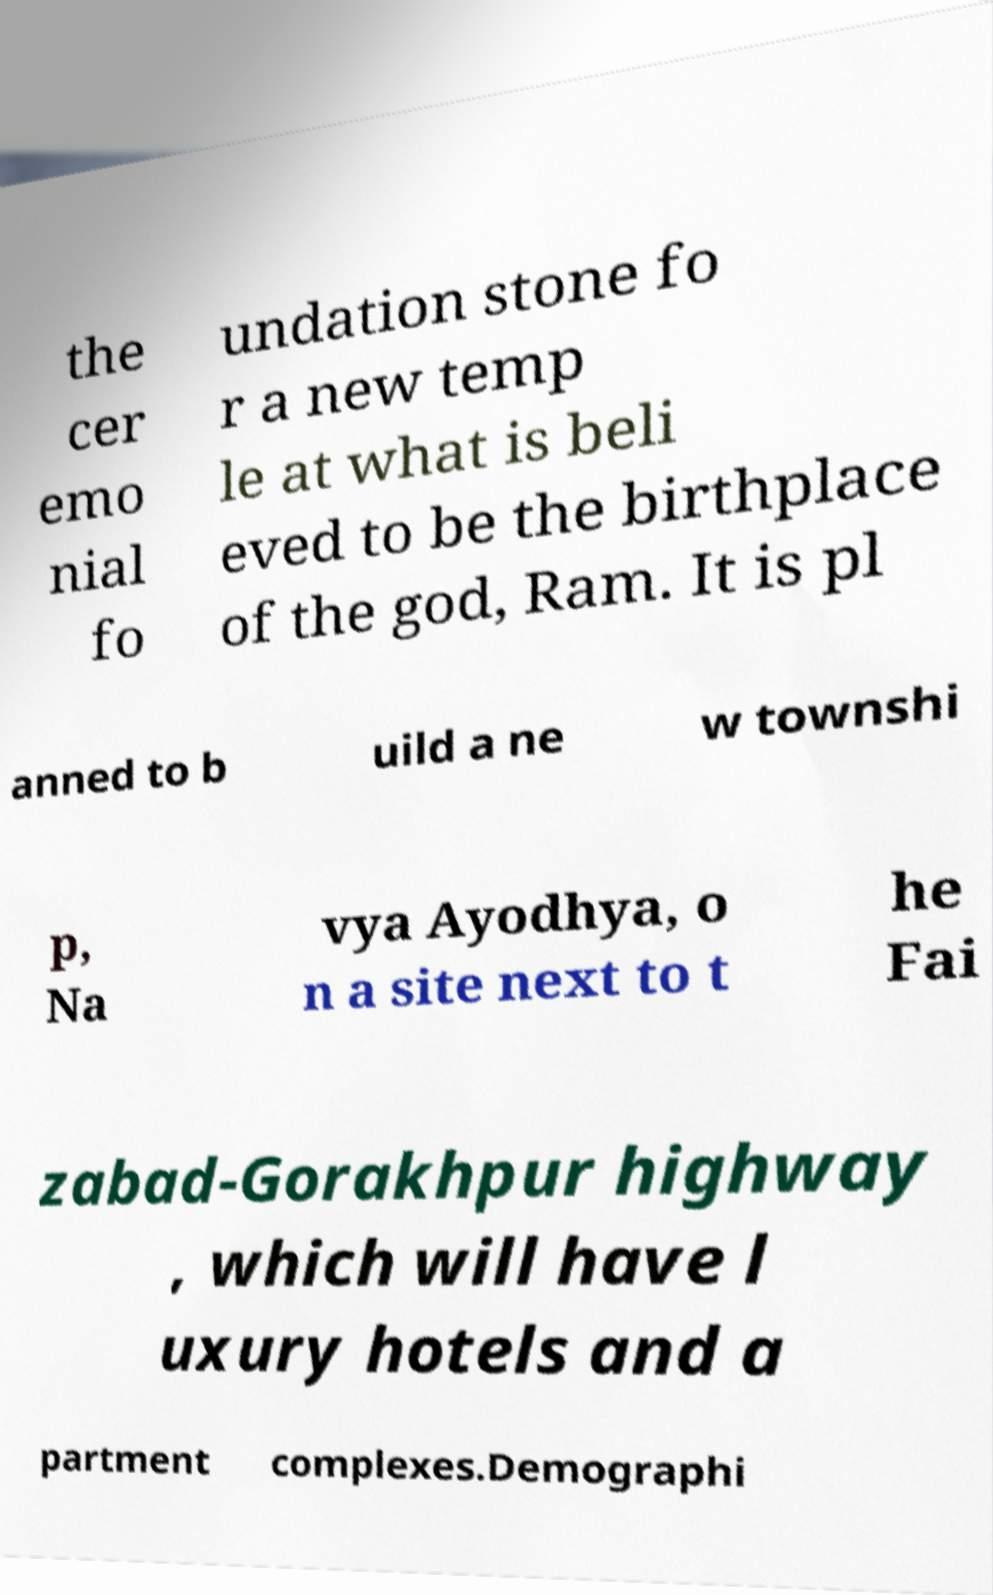Can you accurately transcribe the text from the provided image for me? the cer emo nial fo undation stone fo r a new temp le at what is beli eved to be the birthplace of the god, Ram. It is pl anned to b uild a ne w townshi p, Na vya Ayodhya, o n a site next to t he Fai zabad-Gorakhpur highway , which will have l uxury hotels and a partment complexes.Demographi 